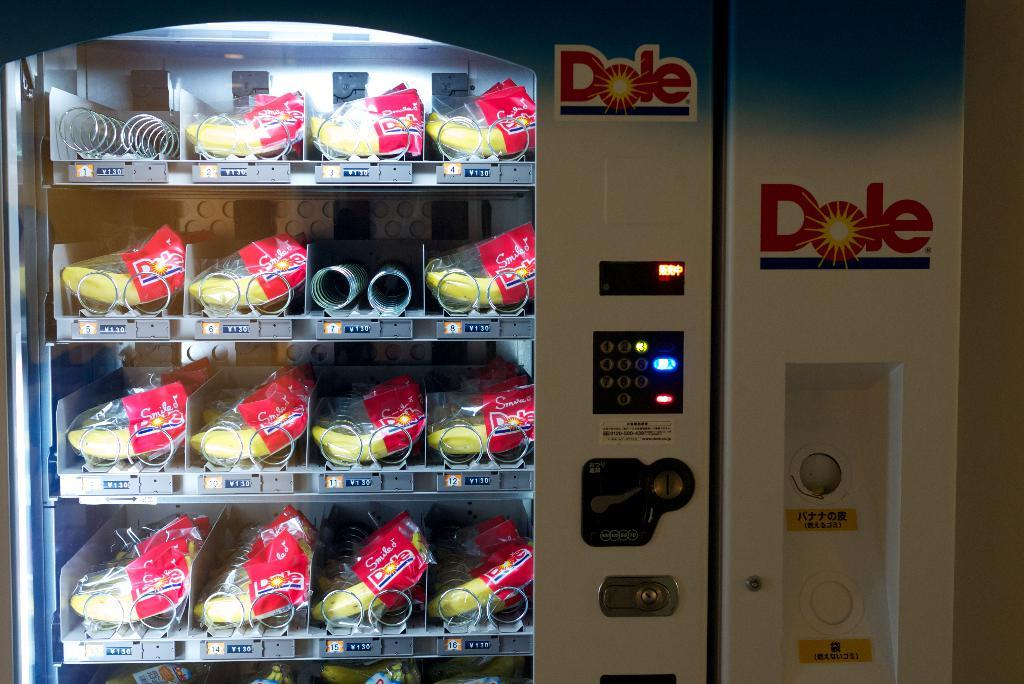<image>
Offer a succinct explanation of the picture presented. A dole vending machine holding many individually wrapped bananas. 